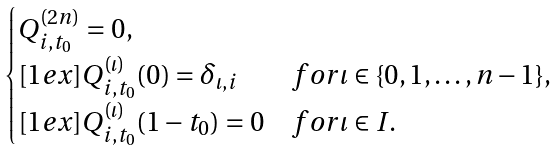<formula> <loc_0><loc_0><loc_500><loc_500>\begin{cases} Q ^ { ( 2 n ) } _ { i , t _ { 0 } } = 0 , \\ [ 1 e x ] Q ^ { ( \iota ) } _ { i , t _ { 0 } } ( 0 ) = \delta _ { \iota , i } & f o r \iota \in \{ 0 , 1 , \dots , n - 1 \} , \\ [ 1 e x ] Q ^ { ( \iota ) } _ { i , t _ { 0 } } ( 1 - t _ { 0 } ) = 0 & f o r \iota \in I . \end{cases}</formula> 